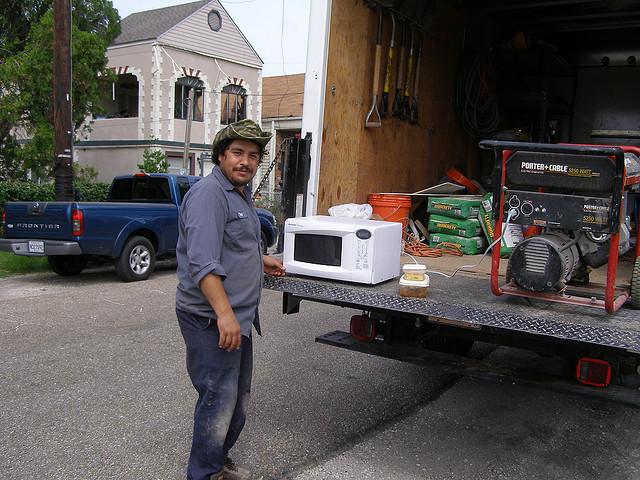Where is the hat?
Answer briefly. Head. Is there anyone standing in the road?
Be succinct. Yes. Is this truck unloading merchandise?
Give a very brief answer. Yes. What are the shovels doing?
Give a very brief answer. Hanging. What color is the man's shirt?
Quick response, please. Blue. Is this man upset?
Concise answer only. No. Could a person sleep comfortably in the foremost vehicle?
Give a very brief answer. No. Is it night time?
Keep it brief. No. Is the man cooking food in the microwave?
Quick response, please. Yes. What is this man waiting for?
Give a very brief answer. Food. How might a short-sighted friend recognize the man out front, even from far away?
Be succinct. Hat. Is the man taller than the truck?
Quick response, please. No. What type of vehicle is behind the man?
Be succinct. Truck. What color is the microwave?
Write a very short answer. White. How many horses are in the truck?
Concise answer only. 0. 